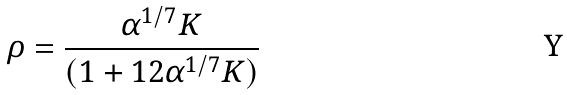<formula> <loc_0><loc_0><loc_500><loc_500>\rho = \frac { \alpha ^ { 1 / 7 } K } { ( 1 + 1 2 \alpha ^ { 1 / 7 } K ) }</formula> 